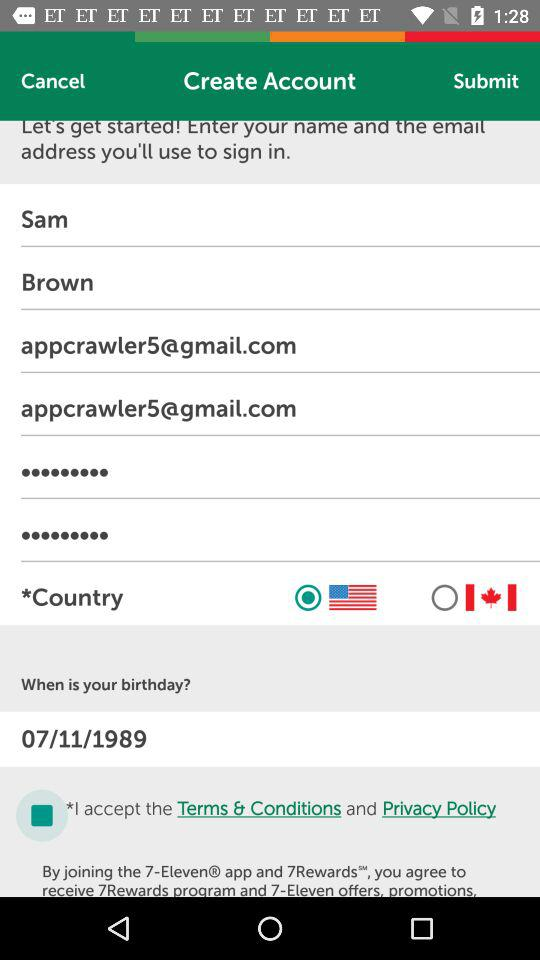What is the status of "Terms & Conditions"? The status is "on". 